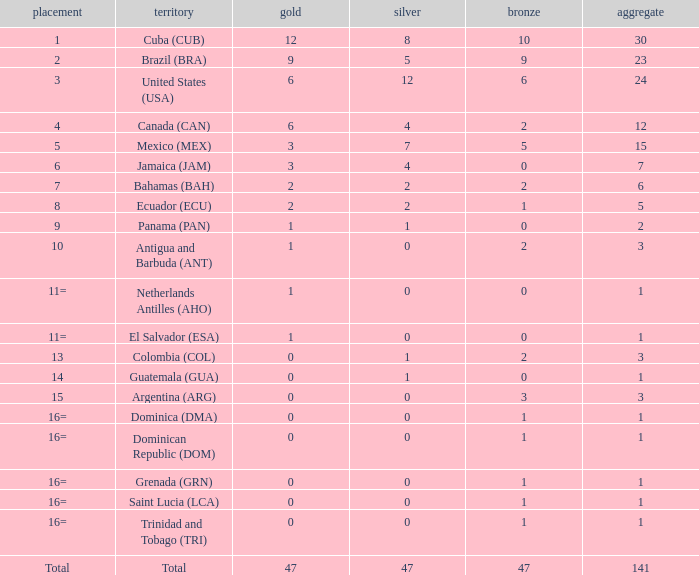What is the total gold with a total less than 1? None. Would you mind parsing the complete table? {'header': ['placement', 'territory', 'gold', 'silver', 'bronze', 'aggregate'], 'rows': [['1', 'Cuba (CUB)', '12', '8', '10', '30'], ['2', 'Brazil (BRA)', '9', '5', '9', '23'], ['3', 'United States (USA)', '6', '12', '6', '24'], ['4', 'Canada (CAN)', '6', '4', '2', '12'], ['5', 'Mexico (MEX)', '3', '7', '5', '15'], ['6', 'Jamaica (JAM)', '3', '4', '0', '7'], ['7', 'Bahamas (BAH)', '2', '2', '2', '6'], ['8', 'Ecuador (ECU)', '2', '2', '1', '5'], ['9', 'Panama (PAN)', '1', '1', '0', '2'], ['10', 'Antigua and Barbuda (ANT)', '1', '0', '2', '3'], ['11=', 'Netherlands Antilles (AHO)', '1', '0', '0', '1'], ['11=', 'El Salvador (ESA)', '1', '0', '0', '1'], ['13', 'Colombia (COL)', '0', '1', '2', '3'], ['14', 'Guatemala (GUA)', '0', '1', '0', '1'], ['15', 'Argentina (ARG)', '0', '0', '3', '3'], ['16=', 'Dominica (DMA)', '0', '0', '1', '1'], ['16=', 'Dominican Republic (DOM)', '0', '0', '1', '1'], ['16=', 'Grenada (GRN)', '0', '0', '1', '1'], ['16=', 'Saint Lucia (LCA)', '0', '0', '1', '1'], ['16=', 'Trinidad and Tobago (TRI)', '0', '0', '1', '1'], ['Total', 'Total', '47', '47', '47', '141']]} 